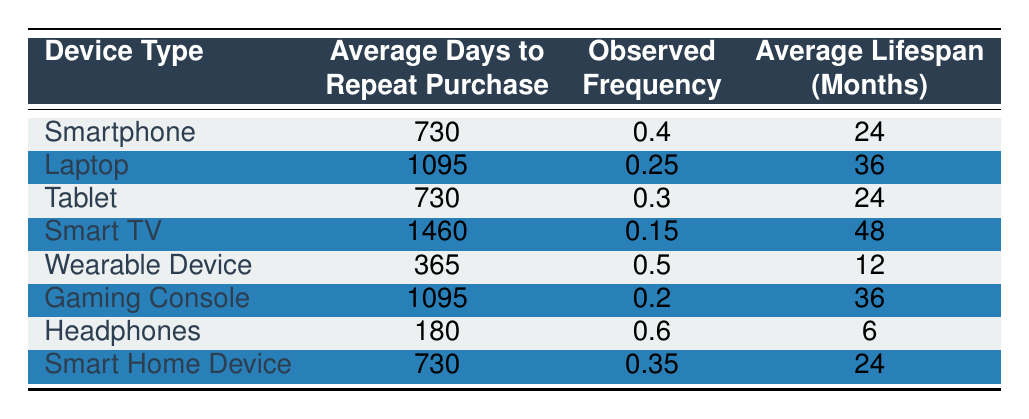What is the average time to repeat purchase for a Wearable Device? The table shows that the average days to repeat purchase for a Wearable Device is 365 days.
Answer: 365 days Which device type has the highest observed frequency of repeat purchases? By examining the 'Observed Frequency' column, Headphones have the highest frequency at 0.6.
Answer: Headphones Calculate the average lifespan in months for all devices with an average days to repeat purchase of 730. The devices with 730 days are Smartphone, Tablet, and Smart Home Device. Their average lifespans are 24 months each. The average is (24 + 24 + 24) / 3 = 24 months.
Answer: 24 months Is the average time to repeat purchase for a Gaming Console greater than 1000 days? The table indicates that the average days to repeat purchase for a Gaming Console is 1095 days, which is greater than 1000 days, therefore the statement is true.
Answer: Yes Which device has the lowest average lifespan? The table shows that Headphones have the lowest average lifespan at 6 months.
Answer: Headphones 